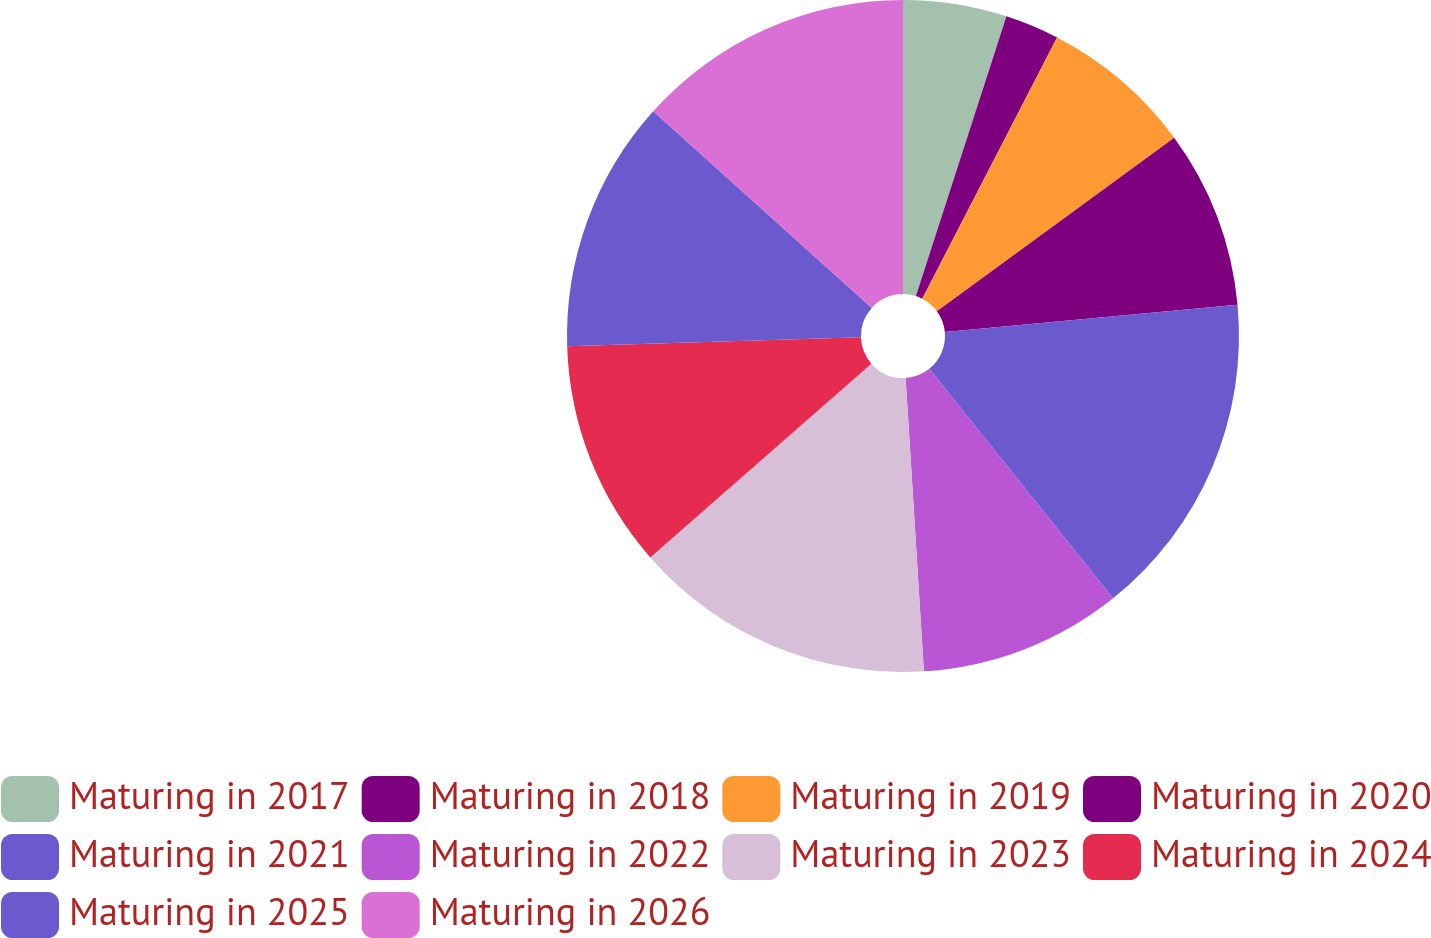<chart> <loc_0><loc_0><loc_500><loc_500><pie_chart><fcel>Maturing in 2017<fcel>Maturing in 2018<fcel>Maturing in 2019<fcel>Maturing in 2020<fcel>Maturing in 2021<fcel>Maturing in 2022<fcel>Maturing in 2023<fcel>Maturing in 2024<fcel>Maturing in 2025<fcel>Maturing in 2026<nl><fcel>4.98%<fcel>2.6%<fcel>7.37%<fcel>8.57%<fcel>15.73%<fcel>9.76%<fcel>14.54%<fcel>10.96%<fcel>12.15%<fcel>13.34%<nl></chart> 